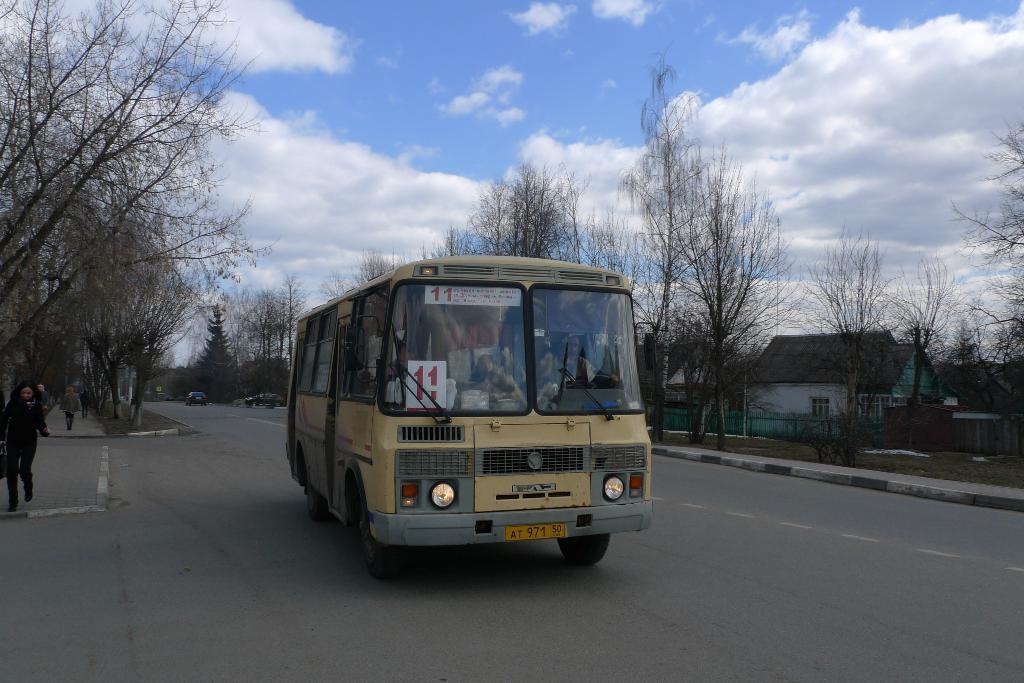How would you summarize this image in a sentence or two? In this picture I can observe yellow color bus on the road. On the right side there is a house. I can observe some trees on either sides of this road. In the background there is a sky with some clouds. 